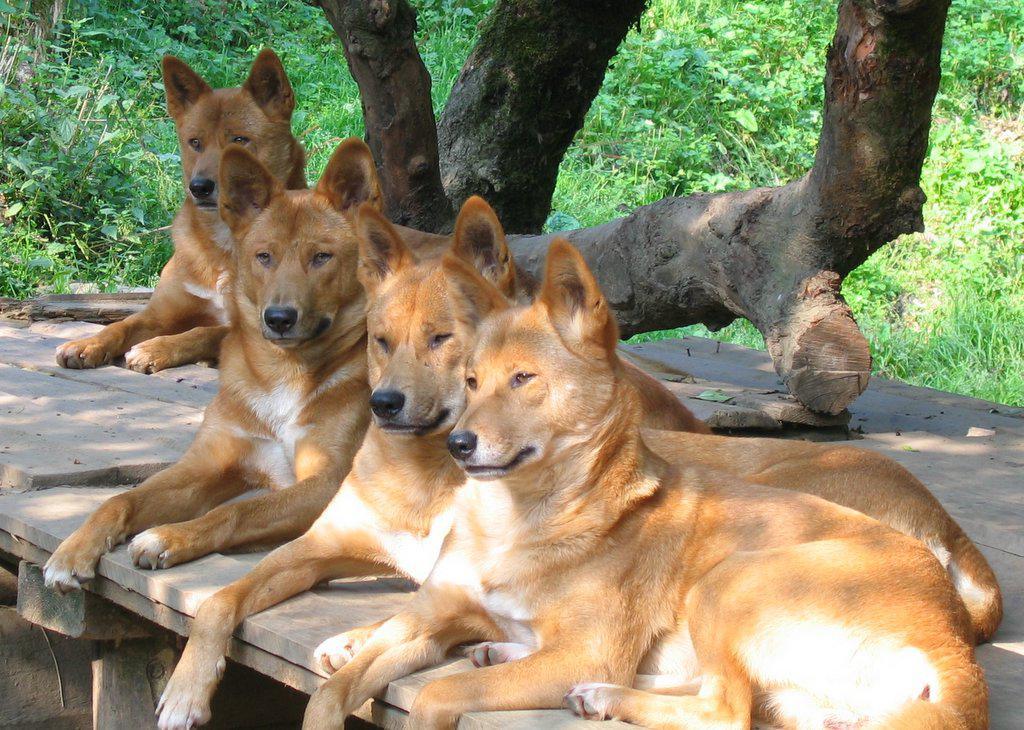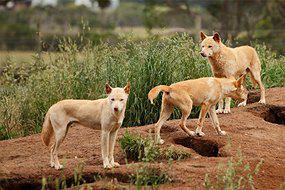The first image is the image on the left, the second image is the image on the right. Analyze the images presented: Is the assertion "There are exactly four coyotes." valid? Answer yes or no. No. 